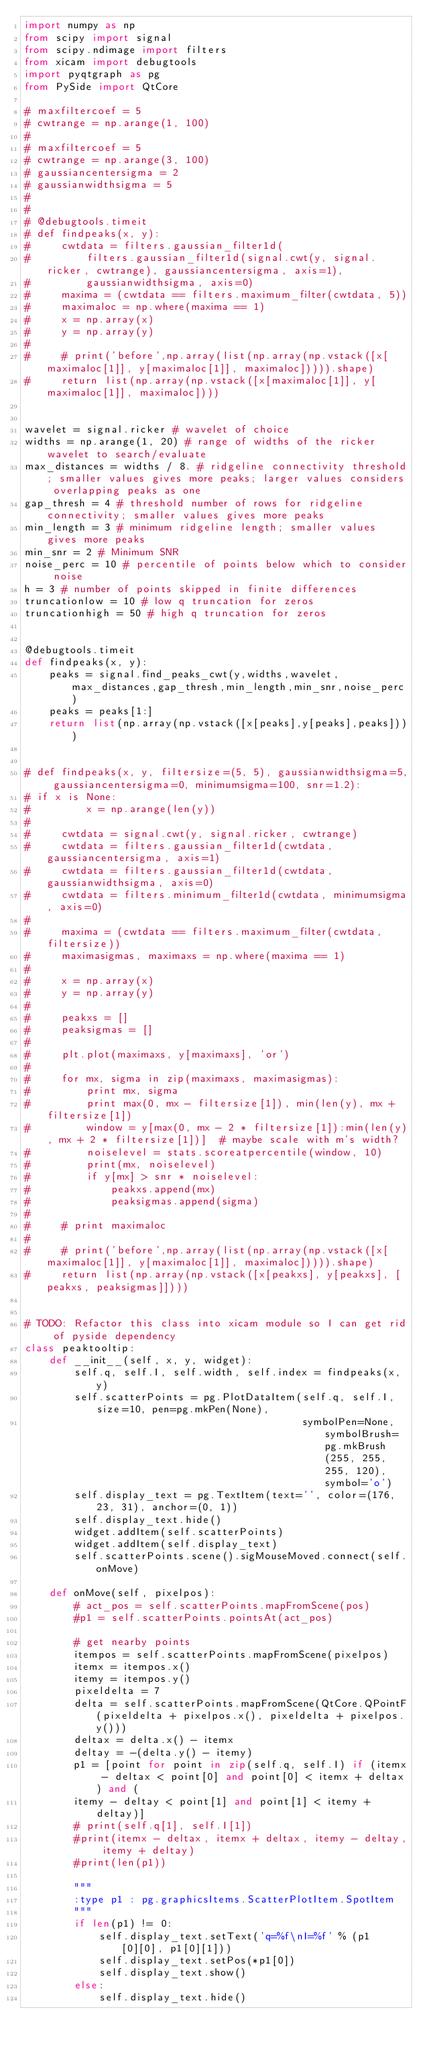Convert code to text. <code><loc_0><loc_0><loc_500><loc_500><_Python_>import numpy as np
from scipy import signal
from scipy.ndimage import filters
from xicam import debugtools
import pyqtgraph as pg
from PySide import QtCore

# maxfiltercoef = 5
# cwtrange = np.arange(1, 100)
#
# maxfiltercoef = 5
# cwtrange = np.arange(3, 100)
# gaussiancentersigma = 2
# gaussianwidthsigma = 5
#
#
# @debugtools.timeit
# def findpeaks(x, y):
#     cwtdata = filters.gaussian_filter1d(
#         filters.gaussian_filter1d(signal.cwt(y, signal.ricker, cwtrange), gaussiancentersigma, axis=1),
#         gaussianwidthsigma, axis=0)
#     maxima = (cwtdata == filters.maximum_filter(cwtdata, 5))
#     maximaloc = np.where(maxima == 1)
#     x = np.array(x)
#     y = np.array(y)
#
#     # print('before',np.array(list(np.array(np.vstack([x[maximaloc[1]], y[maximaloc[1]], maximaloc])))).shape)
#     return list(np.array(np.vstack([x[maximaloc[1]], y[maximaloc[1]], maximaloc])))


wavelet = signal.ricker # wavelet of choice
widths = np.arange(1, 20) # range of widths of the ricker wavelet to search/evaluate
max_distances = widths / 8. # ridgeline connectivity threshold; smaller values gives more peaks; larger values considers overlapping peaks as one
gap_thresh = 4 # threshold number of rows for ridgeline connectivity; smaller values gives more peaks
min_length = 3 # minimum ridgeline length; smaller values gives more peaks
min_snr = 2 # Minimum SNR
noise_perc = 10 # percentile of points below which to consider noise
h = 3 # number of points skipped in finite differences
truncationlow = 10 # low q truncation for zeros
truncationhigh = 50 # high q truncation for zeros


@debugtools.timeit
def findpeaks(x, y):
    peaks = signal.find_peaks_cwt(y,widths,wavelet,max_distances,gap_thresh,min_length,min_snr,noise_perc)
    peaks = peaks[1:]
    return list(np.array(np.vstack([x[peaks],y[peaks],peaks])))


# def findpeaks(x, y, filtersize=(5, 5), gaussianwidthsigma=5, gaussiancentersigma=0, minimumsigma=100, snr=1.2):
# if x is None:
#         x = np.arange(len(y))
#
#     cwtdata = signal.cwt(y, signal.ricker, cwtrange)
#     cwtdata = filters.gaussian_filter1d(cwtdata, gaussiancentersigma, axis=1)
#     cwtdata = filters.gaussian_filter1d(cwtdata, gaussianwidthsigma, axis=0)
#     cwtdata = filters.minimum_filter1d(cwtdata, minimumsigma, axis=0)
#
#     maxima = (cwtdata == filters.maximum_filter(cwtdata, filtersize))
#     maximasigmas, maximaxs = np.where(maxima == 1)
#
#     x = np.array(x)
#     y = np.array(y)
#
#     peakxs = []
#     peaksigmas = []
#
#     plt.plot(maximaxs, y[maximaxs], 'or')
#
#     for mx, sigma in zip(maximaxs, maximasigmas):
#         print mx, sigma
#         print max(0, mx - filtersize[1]), min(len(y), mx + filtersize[1])
#         window = y[max(0, mx - 2 * filtersize[1]):min(len(y), mx + 2 * filtersize[1])]  # maybe scale with m's width?
#         noiselevel = stats.scoreatpercentile(window, 10)
#         print(mx, noiselevel)
#         if y[mx] > snr * noiselevel:
#             peakxs.append(mx)
#             peaksigmas.append(sigma)
#
#     # print maximaloc
#
#     # print('before',np.array(list(np.array(np.vstack([x[maximaloc[1]], y[maximaloc[1]], maximaloc])))).shape)
#     return list(np.array(np.vstack([x[peakxs], y[peakxs], [peakxs, peaksigmas]])))


# TODO: Refactor this class into xicam module so I can get rid of pyside dependency
class peaktooltip:
    def __init__(self, x, y, widget):
        self.q, self.I, self.width, self.index = findpeaks(x, y)
        self.scatterPoints = pg.PlotDataItem(self.q, self.I, size=10, pen=pg.mkPen(None),
                                             symbolPen=None, symbolBrush=pg.mkBrush(255, 255, 255, 120), symbol='o')
        self.display_text = pg.TextItem(text='', color=(176, 23, 31), anchor=(0, 1))
        self.display_text.hide()
        widget.addItem(self.scatterPoints)
        widget.addItem(self.display_text)
        self.scatterPoints.scene().sigMouseMoved.connect(self.onMove)

    def onMove(self, pixelpos):
        # act_pos = self.scatterPoints.mapFromScene(pos)
        #p1 = self.scatterPoints.pointsAt(act_pos)

        # get nearby points
        itempos = self.scatterPoints.mapFromScene(pixelpos)
        itemx = itempos.x()
        itemy = itempos.y()
        pixeldelta = 7
        delta = self.scatterPoints.mapFromScene(QtCore.QPointF(pixeldelta + pixelpos.x(), pixeldelta + pixelpos.y()))
        deltax = delta.x() - itemx
        deltay = -(delta.y() - itemy)
        p1 = [point for point in zip(self.q, self.I) if (itemx - deltax < point[0] and point[0] < itemx + deltax) and (
        itemy - deltay < point[1] and point[1] < itemy + deltay)]
        # print(self.q[1], self.I[1])
        #print(itemx - deltax, itemx + deltax, itemy - deltay, itemy + deltay)
        #print(len(p1))

        """
        :type p1 : pg.graphicsItems.ScatterPlotItem.SpotItem
        """
        if len(p1) != 0:
            self.display_text.setText('q=%f\nI=%f' % (p1[0][0], p1[0][1]))
            self.display_text.setPos(*p1[0])
            self.display_text.show()
        else:
            self.display_text.hide()


</code> 